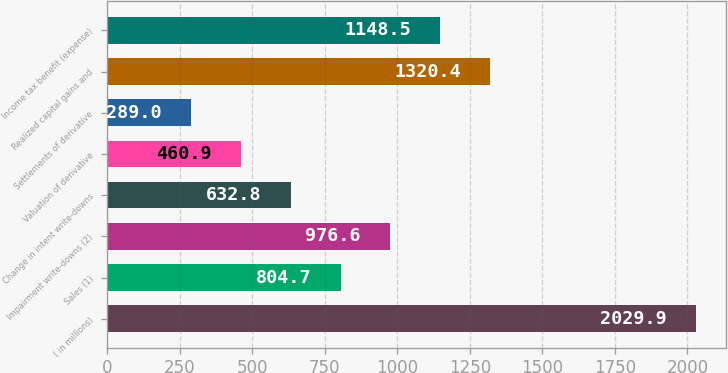Convert chart to OTSL. <chart><loc_0><loc_0><loc_500><loc_500><bar_chart><fcel>( in millions)<fcel>Sales (1)<fcel>Impairment write-downs (2)<fcel>Change in intent write-downs<fcel>Valuation of derivative<fcel>Settlements of derivative<fcel>Realized capital gains and<fcel>Income tax benefit (expense)<nl><fcel>2029.9<fcel>804.7<fcel>976.6<fcel>632.8<fcel>460.9<fcel>289<fcel>1320.4<fcel>1148.5<nl></chart> 